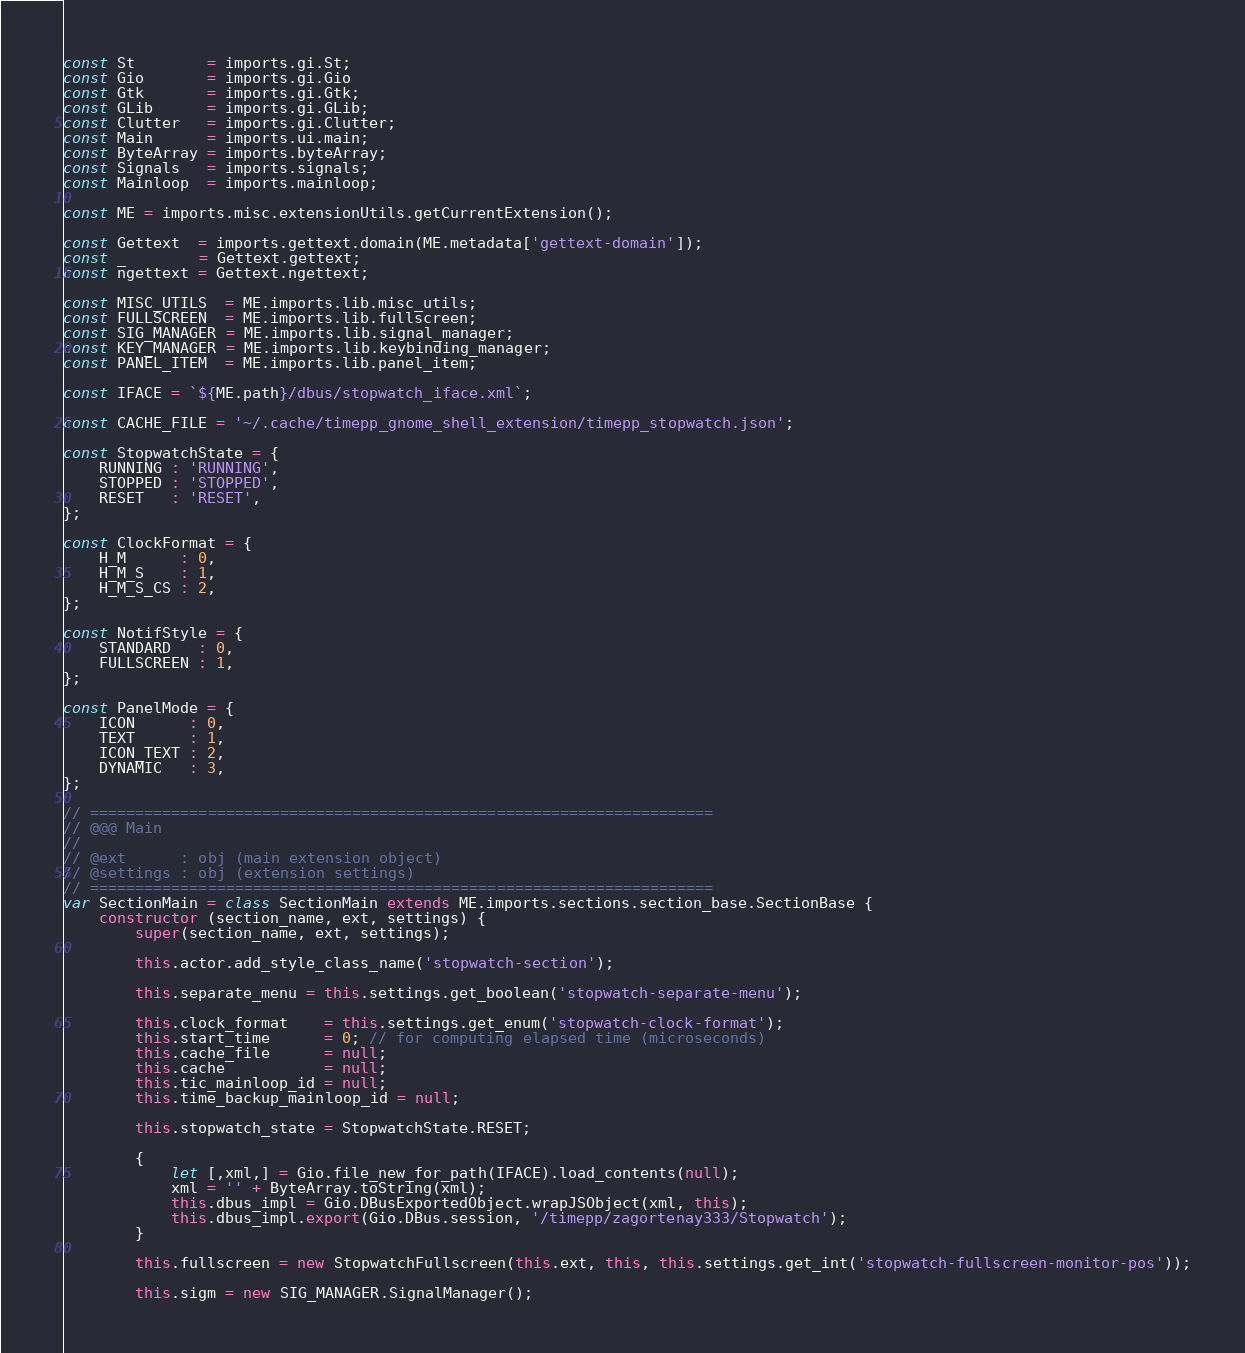<code> <loc_0><loc_0><loc_500><loc_500><_JavaScript_>const St        = imports.gi.St;
const Gio       = imports.gi.Gio
const Gtk       = imports.gi.Gtk;
const GLib      = imports.gi.GLib;
const Clutter   = imports.gi.Clutter;
const Main      = imports.ui.main;
const ByteArray = imports.byteArray;
const Signals   = imports.signals;
const Mainloop  = imports.mainloop;

const ME = imports.misc.extensionUtils.getCurrentExtension();

const Gettext  = imports.gettext.domain(ME.metadata['gettext-domain']);
const _        = Gettext.gettext;
const ngettext = Gettext.ngettext;

const MISC_UTILS  = ME.imports.lib.misc_utils;
const FULLSCREEN  = ME.imports.lib.fullscreen;
const SIG_MANAGER = ME.imports.lib.signal_manager;
const KEY_MANAGER = ME.imports.lib.keybinding_manager;
const PANEL_ITEM  = ME.imports.lib.panel_item;

const IFACE = `${ME.path}/dbus/stopwatch_iface.xml`;

const CACHE_FILE = '~/.cache/timepp_gnome_shell_extension/timepp_stopwatch.json';

const StopwatchState = {
    RUNNING : 'RUNNING',
    STOPPED : 'STOPPED',
    RESET   : 'RESET',
};

const ClockFormat = {
    H_M      : 0,
    H_M_S    : 1,
    H_M_S_CS : 2,
};

const NotifStyle = {
    STANDARD   : 0,
    FULLSCREEN : 1,
};

const PanelMode = {
    ICON      : 0,
    TEXT      : 1,
    ICON_TEXT : 2,
    DYNAMIC   : 3,
};

// =====================================================================
// @@@ Main
//
// @ext      : obj (main extension object)
// @settings : obj (extension settings)
// =====================================================================
var SectionMain = class SectionMain extends ME.imports.sections.section_base.SectionBase {
    constructor (section_name, ext, settings) {
        super(section_name, ext, settings);

        this.actor.add_style_class_name('stopwatch-section');

        this.separate_menu = this.settings.get_boolean('stopwatch-separate-menu');

        this.clock_format    = this.settings.get_enum('stopwatch-clock-format');
        this.start_time      = 0; // for computing elapsed time (microseconds)
        this.cache_file      = null;
        this.cache           = null;
        this.tic_mainloop_id = null;
        this.time_backup_mainloop_id = null;

        this.stopwatch_state = StopwatchState.RESET;

        {
            let [,xml,] = Gio.file_new_for_path(IFACE).load_contents(null);
            xml = '' + ByteArray.toString(xml);
            this.dbus_impl = Gio.DBusExportedObject.wrapJSObject(xml, this);
            this.dbus_impl.export(Gio.DBus.session, '/timepp/zagortenay333/Stopwatch');
        }

        this.fullscreen = new StopwatchFullscreen(this.ext, this, this.settings.get_int('stopwatch-fullscreen-monitor-pos'));

        this.sigm = new SIG_MANAGER.SignalManager();</code> 